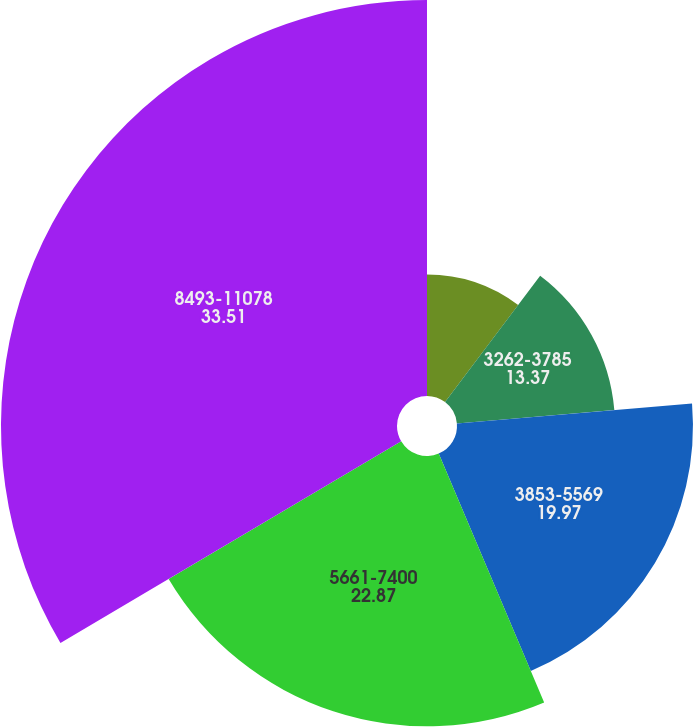Convert chart. <chart><loc_0><loc_0><loc_500><loc_500><pie_chart><fcel>1687-3246<fcel>3262-3785<fcel>3853-5569<fcel>5661-7400<fcel>8493-11078<nl><fcel>10.28%<fcel>13.37%<fcel>19.97%<fcel>22.87%<fcel>33.51%<nl></chart> 